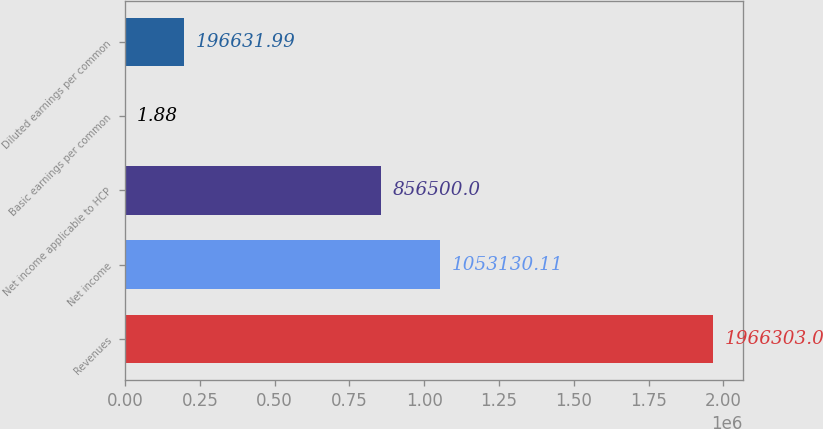Convert chart. <chart><loc_0><loc_0><loc_500><loc_500><bar_chart><fcel>Revenues<fcel>Net income<fcel>Net income applicable to HCP<fcel>Basic earnings per common<fcel>Diluted earnings per common<nl><fcel>1.9663e+06<fcel>1.05313e+06<fcel>856500<fcel>1.88<fcel>196632<nl></chart> 